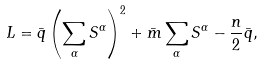<formula> <loc_0><loc_0><loc_500><loc_500>L = \bar { q } \left ( \sum _ { \alpha } S ^ { \alpha } \right ) ^ { 2 } + \bar { m } \sum _ { \alpha } S ^ { \alpha } - \frac { n } { 2 } \bar { q } ,</formula> 